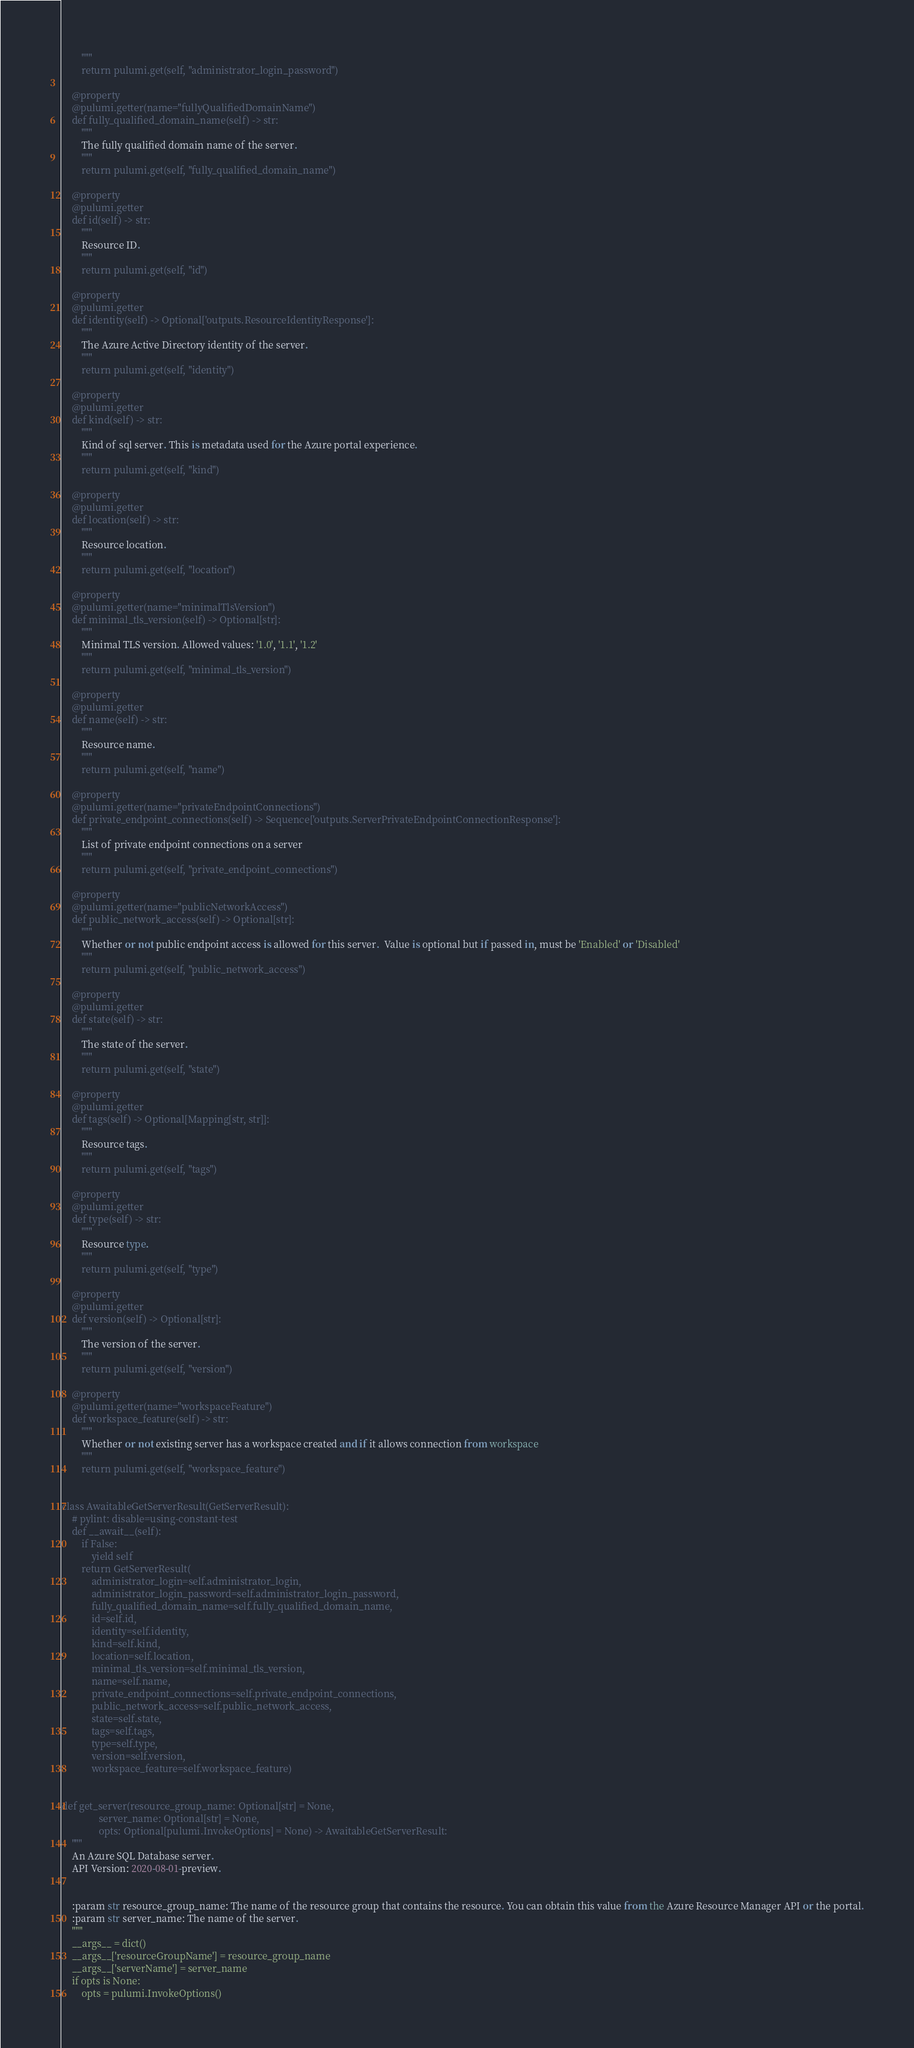<code> <loc_0><loc_0><loc_500><loc_500><_Python_>        """
        return pulumi.get(self, "administrator_login_password")

    @property
    @pulumi.getter(name="fullyQualifiedDomainName")
    def fully_qualified_domain_name(self) -> str:
        """
        The fully qualified domain name of the server.
        """
        return pulumi.get(self, "fully_qualified_domain_name")

    @property
    @pulumi.getter
    def id(self) -> str:
        """
        Resource ID.
        """
        return pulumi.get(self, "id")

    @property
    @pulumi.getter
    def identity(self) -> Optional['outputs.ResourceIdentityResponse']:
        """
        The Azure Active Directory identity of the server.
        """
        return pulumi.get(self, "identity")

    @property
    @pulumi.getter
    def kind(self) -> str:
        """
        Kind of sql server. This is metadata used for the Azure portal experience.
        """
        return pulumi.get(self, "kind")

    @property
    @pulumi.getter
    def location(self) -> str:
        """
        Resource location.
        """
        return pulumi.get(self, "location")

    @property
    @pulumi.getter(name="minimalTlsVersion")
    def minimal_tls_version(self) -> Optional[str]:
        """
        Minimal TLS version. Allowed values: '1.0', '1.1', '1.2'
        """
        return pulumi.get(self, "minimal_tls_version")

    @property
    @pulumi.getter
    def name(self) -> str:
        """
        Resource name.
        """
        return pulumi.get(self, "name")

    @property
    @pulumi.getter(name="privateEndpointConnections")
    def private_endpoint_connections(self) -> Sequence['outputs.ServerPrivateEndpointConnectionResponse']:
        """
        List of private endpoint connections on a server
        """
        return pulumi.get(self, "private_endpoint_connections")

    @property
    @pulumi.getter(name="publicNetworkAccess")
    def public_network_access(self) -> Optional[str]:
        """
        Whether or not public endpoint access is allowed for this server.  Value is optional but if passed in, must be 'Enabled' or 'Disabled'
        """
        return pulumi.get(self, "public_network_access")

    @property
    @pulumi.getter
    def state(self) -> str:
        """
        The state of the server.
        """
        return pulumi.get(self, "state")

    @property
    @pulumi.getter
    def tags(self) -> Optional[Mapping[str, str]]:
        """
        Resource tags.
        """
        return pulumi.get(self, "tags")

    @property
    @pulumi.getter
    def type(self) -> str:
        """
        Resource type.
        """
        return pulumi.get(self, "type")

    @property
    @pulumi.getter
    def version(self) -> Optional[str]:
        """
        The version of the server.
        """
        return pulumi.get(self, "version")

    @property
    @pulumi.getter(name="workspaceFeature")
    def workspace_feature(self) -> str:
        """
        Whether or not existing server has a workspace created and if it allows connection from workspace
        """
        return pulumi.get(self, "workspace_feature")


class AwaitableGetServerResult(GetServerResult):
    # pylint: disable=using-constant-test
    def __await__(self):
        if False:
            yield self
        return GetServerResult(
            administrator_login=self.administrator_login,
            administrator_login_password=self.administrator_login_password,
            fully_qualified_domain_name=self.fully_qualified_domain_name,
            id=self.id,
            identity=self.identity,
            kind=self.kind,
            location=self.location,
            minimal_tls_version=self.minimal_tls_version,
            name=self.name,
            private_endpoint_connections=self.private_endpoint_connections,
            public_network_access=self.public_network_access,
            state=self.state,
            tags=self.tags,
            type=self.type,
            version=self.version,
            workspace_feature=self.workspace_feature)


def get_server(resource_group_name: Optional[str] = None,
               server_name: Optional[str] = None,
               opts: Optional[pulumi.InvokeOptions] = None) -> AwaitableGetServerResult:
    """
    An Azure SQL Database server.
    API Version: 2020-08-01-preview.


    :param str resource_group_name: The name of the resource group that contains the resource. You can obtain this value from the Azure Resource Manager API or the portal.
    :param str server_name: The name of the server.
    """
    __args__ = dict()
    __args__['resourceGroupName'] = resource_group_name
    __args__['serverName'] = server_name
    if opts is None:
        opts = pulumi.InvokeOptions()</code> 